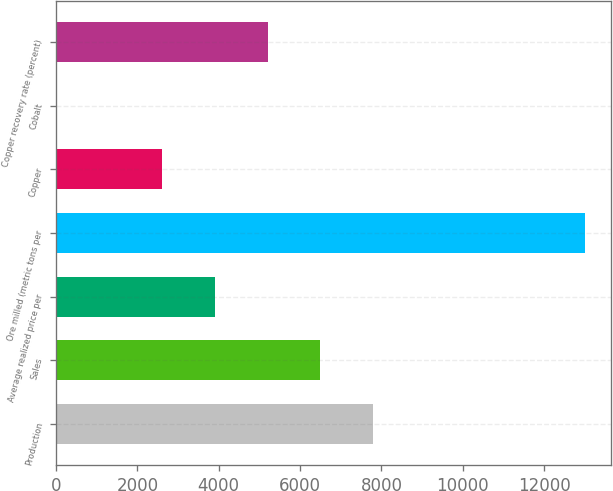Convert chart. <chart><loc_0><loc_0><loc_500><loc_500><bar_chart><fcel>Production<fcel>Sales<fcel>Average realized price per<fcel>Ore milled (metric tons per<fcel>Copper<fcel>Cobalt<fcel>Copper recovery rate (percent)<nl><fcel>7800.13<fcel>6500.17<fcel>3900.25<fcel>13000<fcel>2600.29<fcel>0.37<fcel>5200.21<nl></chart> 